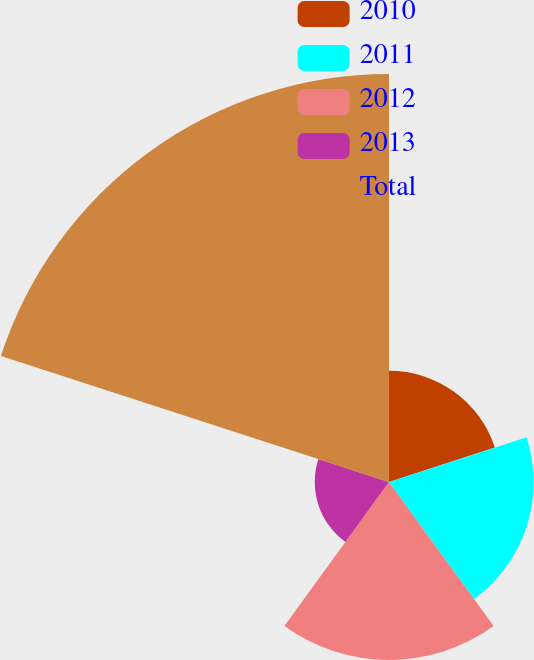Convert chart to OTSL. <chart><loc_0><loc_0><loc_500><loc_500><pie_chart><fcel>2010<fcel>2011<fcel>2012<fcel>2013<fcel>Total<nl><fcel>12.15%<fcel>15.79%<fcel>19.43%<fcel>8.1%<fcel>44.53%<nl></chart> 